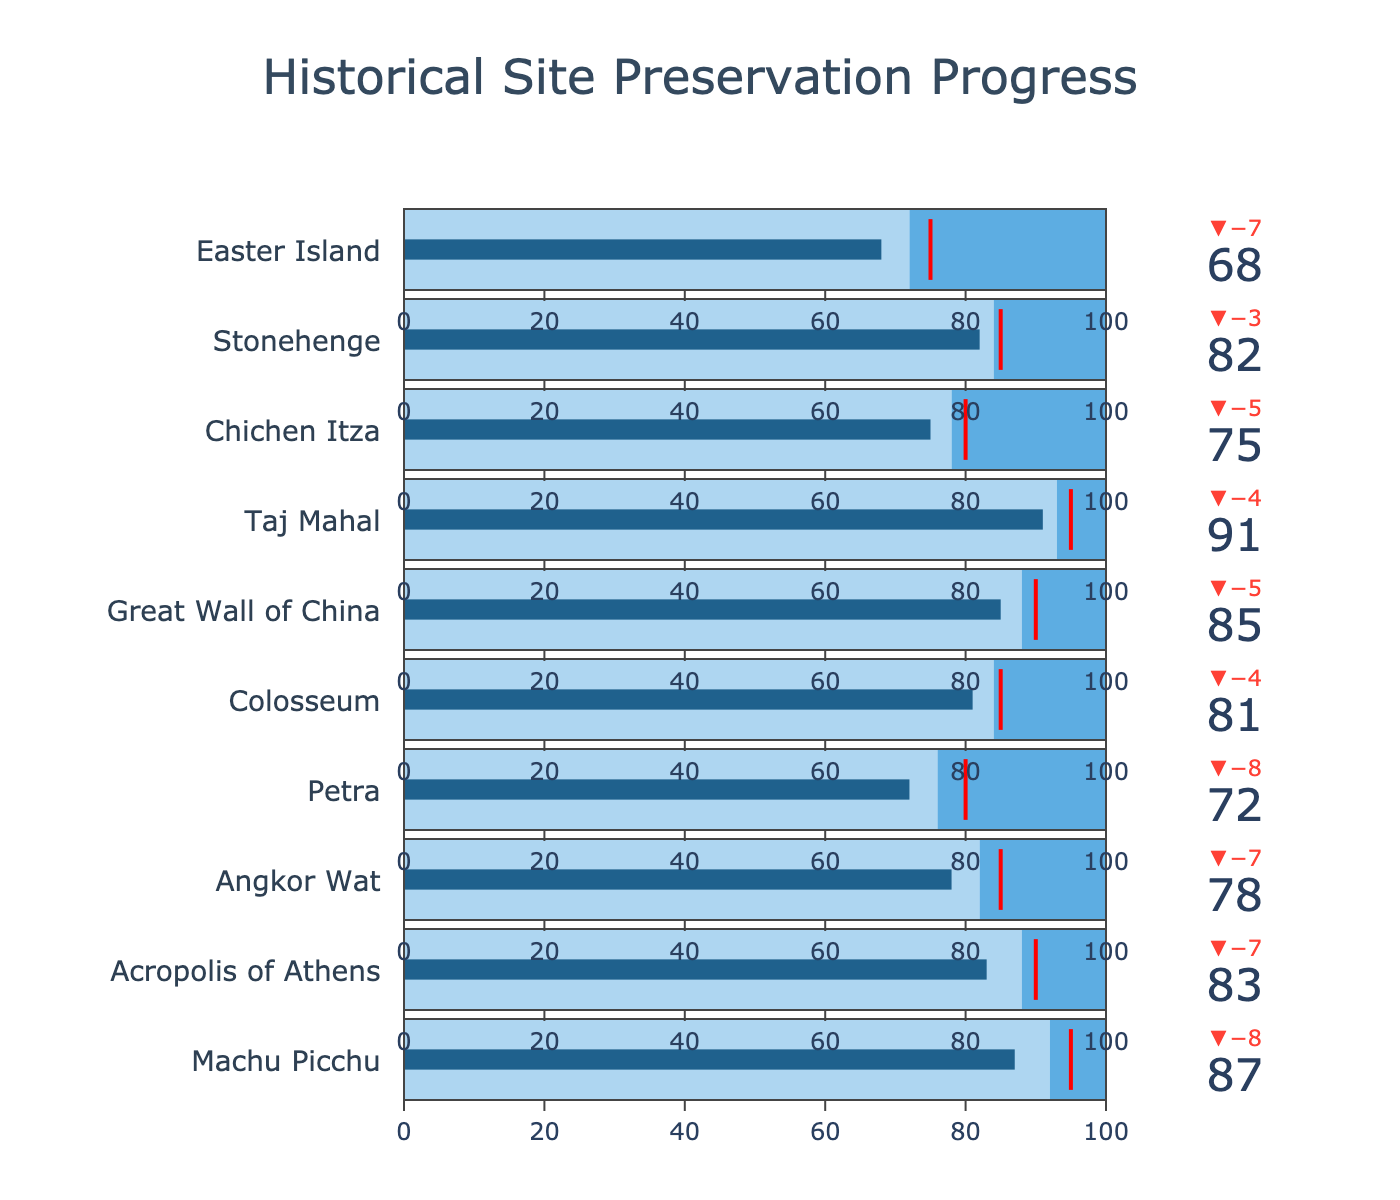what is the title of the chart? The title is displayed at the top of the chart, usually in larger font size and centered. It directly indicates what the entire chart is about.
Answer: Historical Site Preservation Progress Which site has the highest actual preservation progress? To determine this, I compare the 'Actual' values for each site. The highest number represents the highest actual preservation progress.
Answer: Taj Mahal Are there any sites where the actual preservation progress exceeds the target? I compare the 'Actual' values to the 'Target' values for each site. If 'Actual' is greater than 'Target', that site exceeds its target.
Answer: No What's the difference between the 'Actual' and 'Comparative' values for Petra? I subtract the 'Comparative' value from the 'Actual' value for Petra. The respective values are: Actual = 72, Comparative = 76. 72 - 76 = -4
Answer: -4 Which site has the smallest gap between the actual and target preservation progress? To find the smallest gap, I compute the absolute difference between 'Actual' and 'Target' for each site and compare them.
Answer: Colosseum How many sites have a comparative value above 80? Counting the 'Comparative' values that exceed 80 by looking at each site's Comparative value.
Answer: 6 Which site is closest to its preservation target and what is its actual progress? The closest site will have the smallest absolute difference between 'Actual' and 'Target'. By evaluating each site's values, I find the smallest difference.
Answer: Taj Mahal with actual progress of 91 How does the actual preservation of Chichen Itza compare with that of the Great Wall of China? I compare the Actual values of Chichen Itza and the Great Wall of China. By checking both, I observe which is higher. Chichen Itza has 75, and Great Wall of China has 85.
Answer: Great Wall of China has higher actual preservation Which site has the lowest actual progress? I look at the 'Actual' values of all sites and identify the smallest number.
Answer: Easter Island What's the average target preservation progress across all sites? To find the average target, I sum all 'Target' values and divide by the number of sites (10). The sum is 870 which gives an average of 870/10.
Answer: 87 